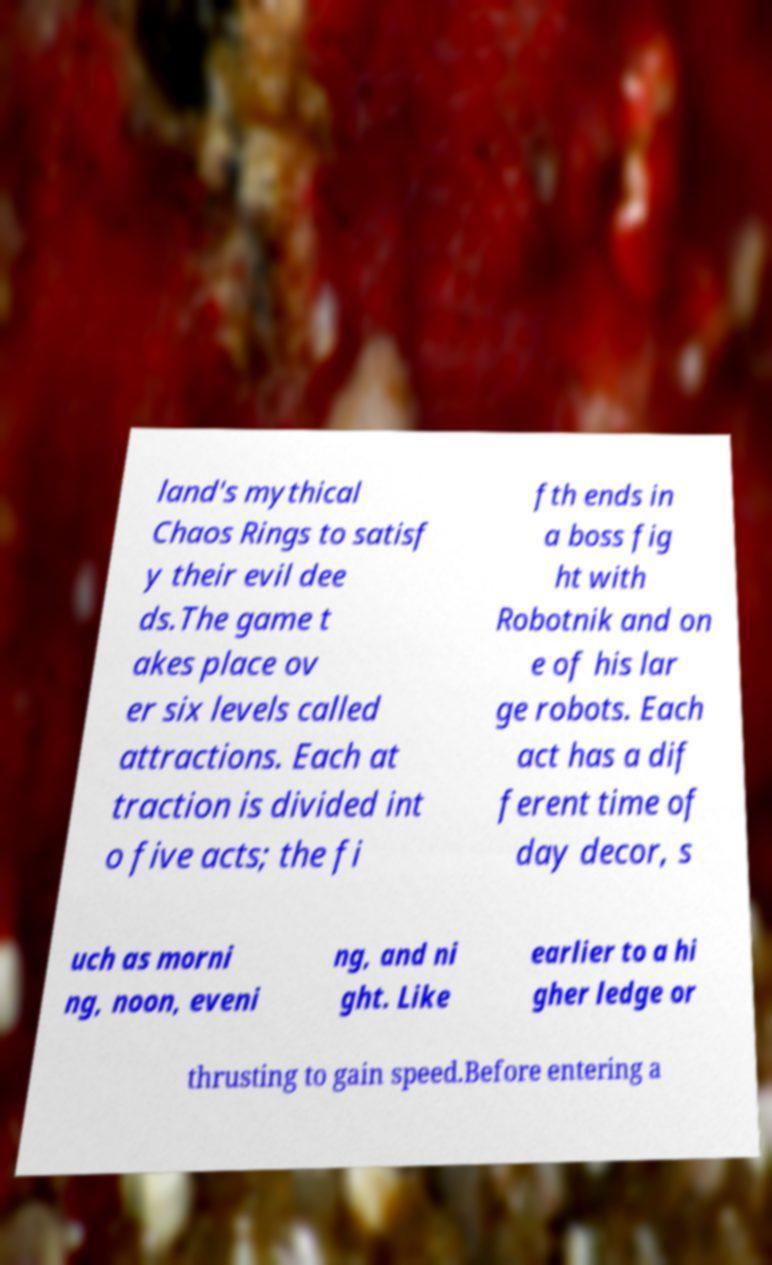Please identify and transcribe the text found in this image. land's mythical Chaos Rings to satisf y their evil dee ds.The game t akes place ov er six levels called attractions. Each at traction is divided int o five acts; the fi fth ends in a boss fig ht with Robotnik and on e of his lar ge robots. Each act has a dif ferent time of day decor, s uch as morni ng, noon, eveni ng, and ni ght. Like earlier to a hi gher ledge or thrusting to gain speed.Before entering a 